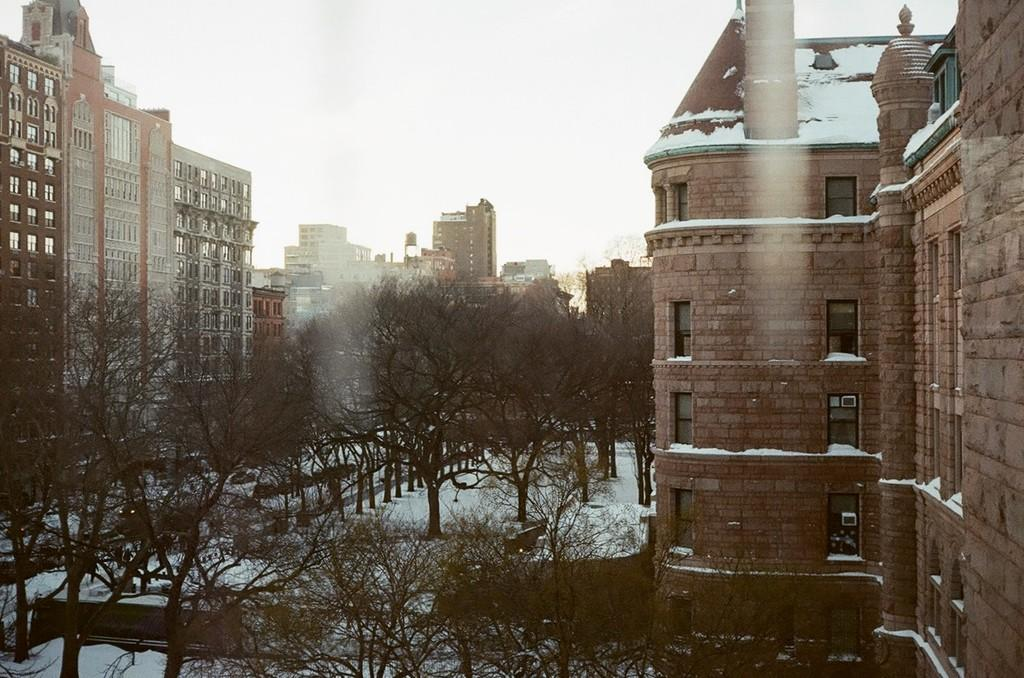What type of structures can be seen in the image? There are buildings in the image. What feature is visible on the buildings? There are windows visible in the image. What type of vegetation is present in the image? There are trees in the image. What type of seating is available in the image? There is a bench in the image. What is the weather like in the image? There is snow in the image, indicating a cold or wintery environment. What can be seen in the background of the image? The sky is visible in the background of the image. What type of furniture is being operated in the image? There is no furniture being operated in the image; the focus is on the buildings, windows, trees, bench, snow, and sky. 